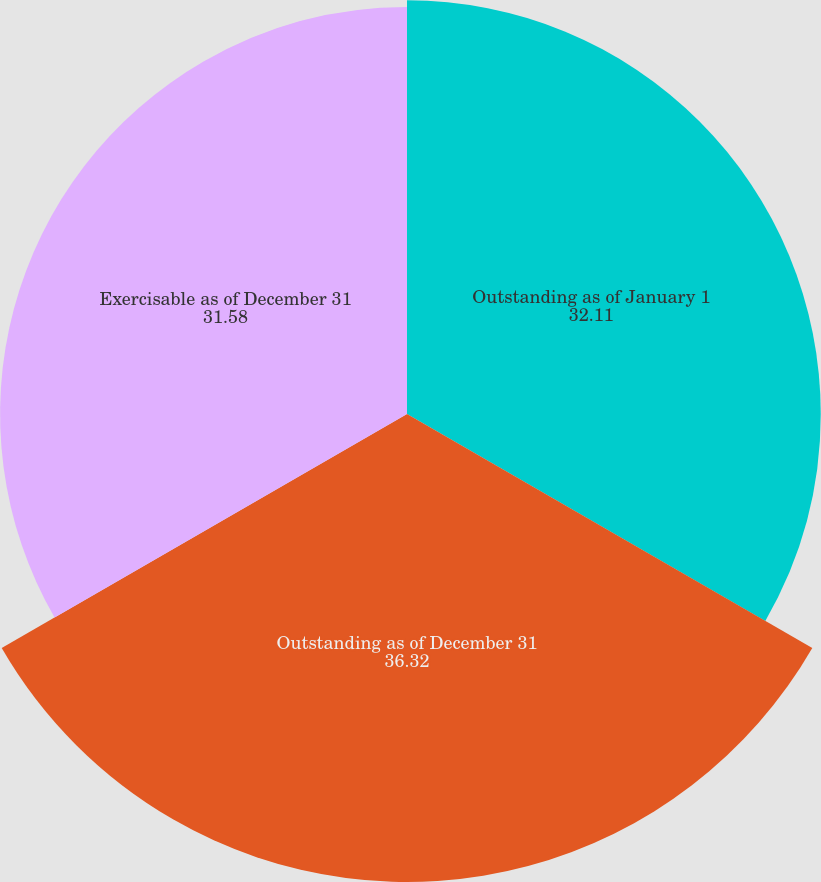Convert chart to OTSL. <chart><loc_0><loc_0><loc_500><loc_500><pie_chart><fcel>Outstanding as of January 1<fcel>Outstanding as of December 31<fcel>Exercisable as of December 31<nl><fcel>32.11%<fcel>36.32%<fcel>31.58%<nl></chart> 